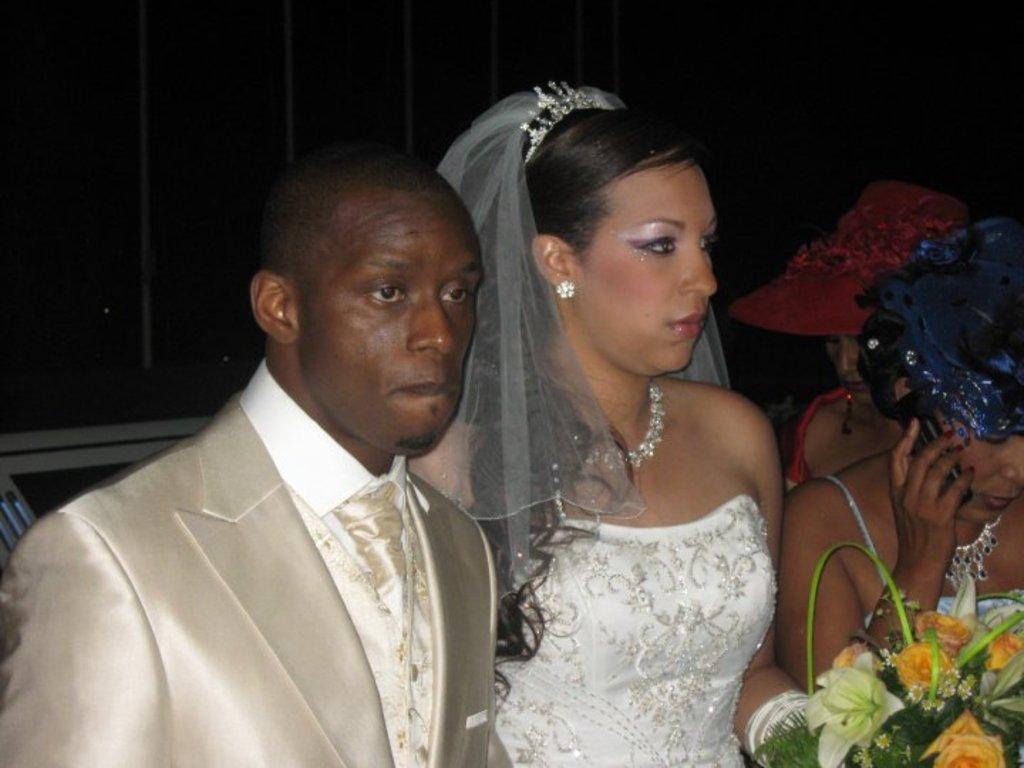Can you describe this image briefly? In this image, we can see a bride and groom in a white dress. On the right side, we can see a flower bouquet and two women. Background there is a wall. Here we can see a woman is holding a mobile and the other woman is wearing a hat. 